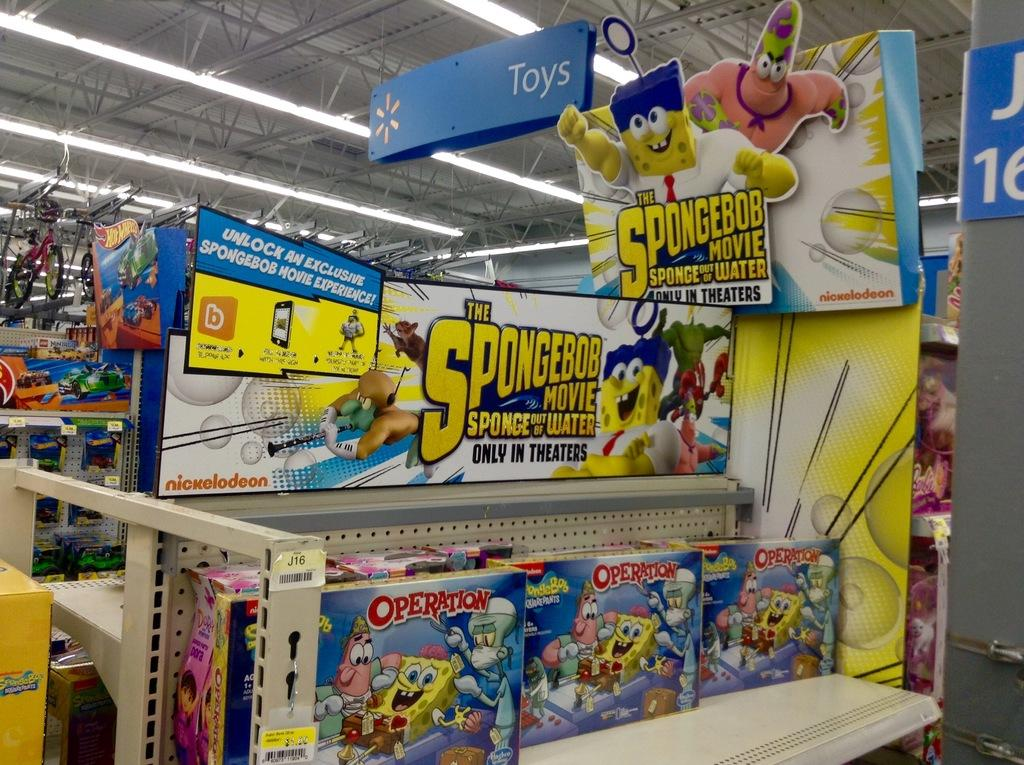<image>
Provide a brief description of the given image. A lot of spongebob products under the sign that says "toys" 